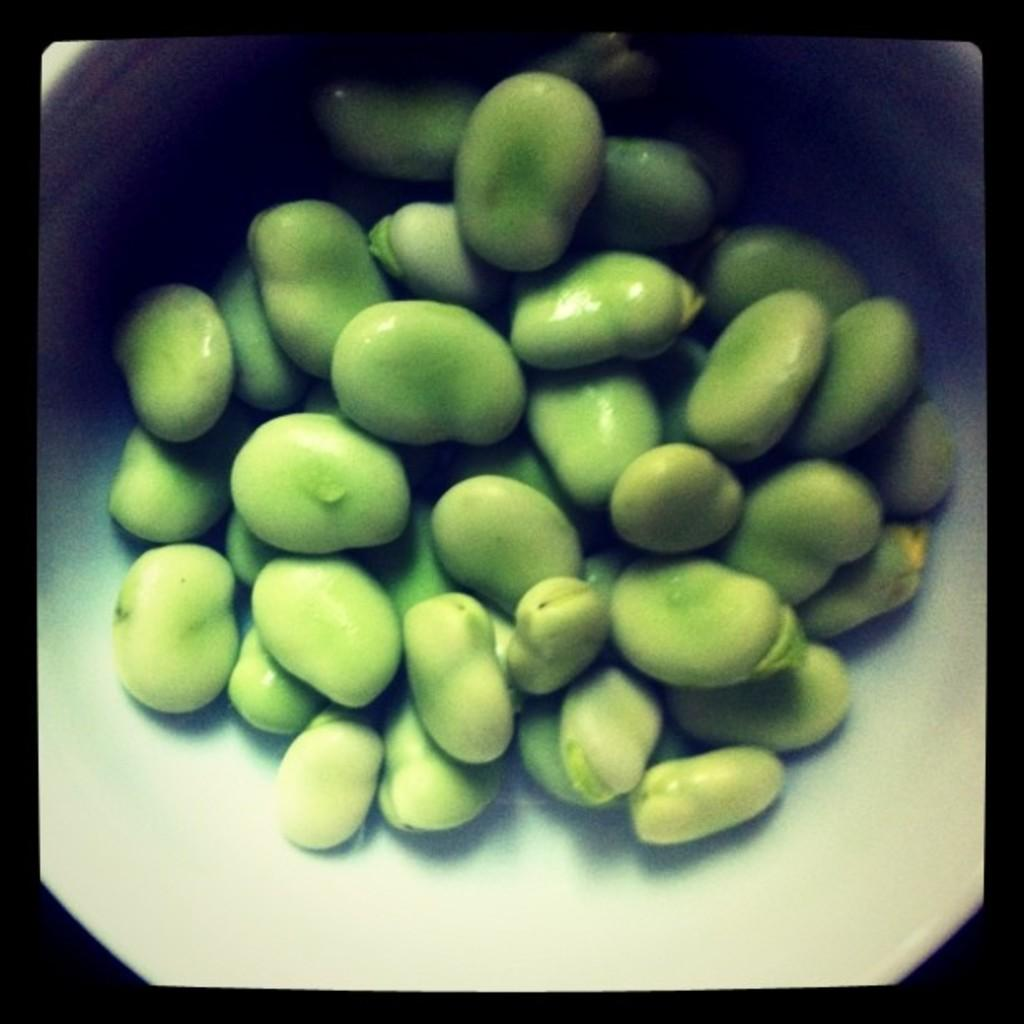What is present in the image? There are seeds in the image. How are the seeds contained or stored? The seeds are kept in a bowl. What type of dress is hanging on the wall in the image? There is no dress present in the image; it only features seeds in a bowl. 